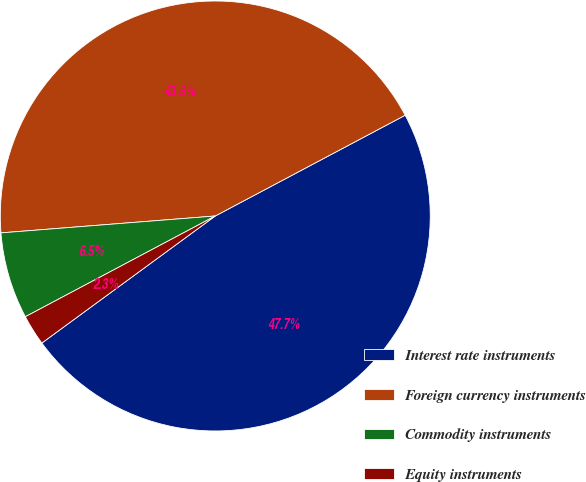<chart> <loc_0><loc_0><loc_500><loc_500><pie_chart><fcel>Interest rate instruments<fcel>Foreign currency instruments<fcel>Commodity instruments<fcel>Equity instruments<nl><fcel>47.7%<fcel>43.49%<fcel>6.51%<fcel>2.3%<nl></chart> 